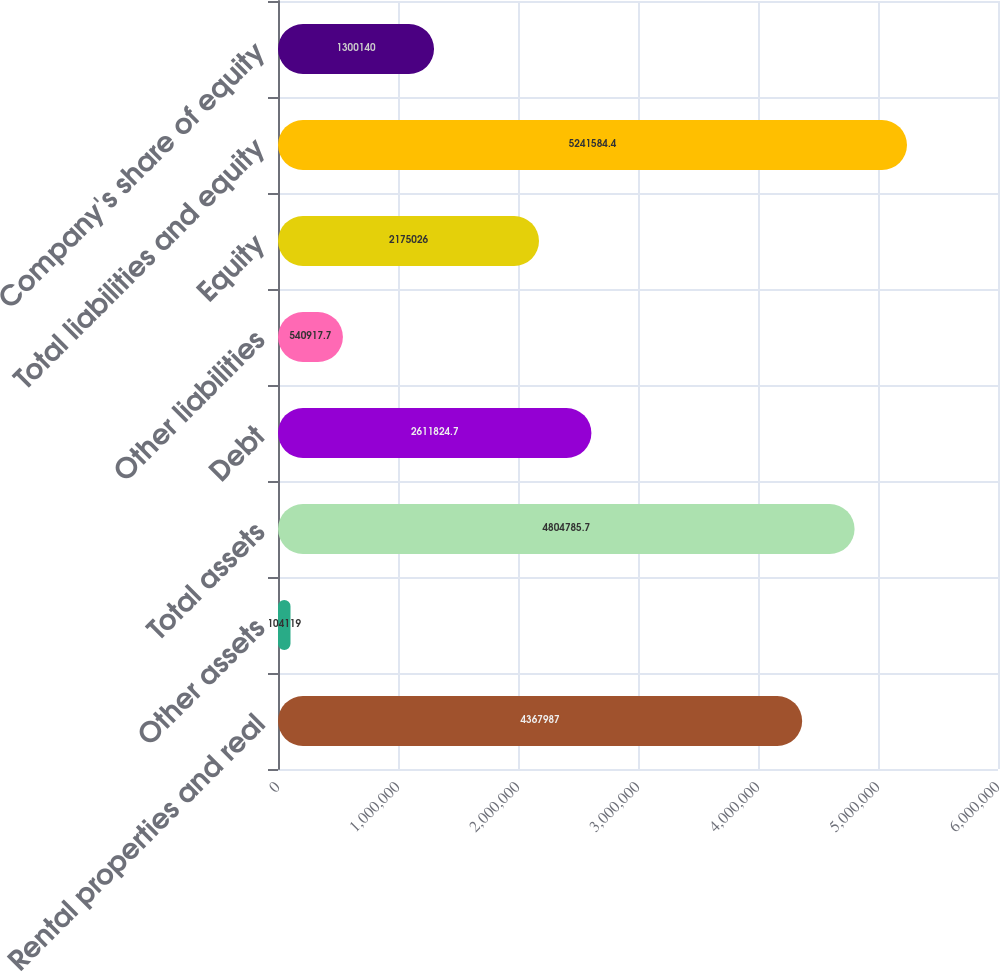Convert chart. <chart><loc_0><loc_0><loc_500><loc_500><bar_chart><fcel>Rental properties and real<fcel>Other assets<fcel>Total assets<fcel>Debt<fcel>Other liabilities<fcel>Equity<fcel>Total liabilities and equity<fcel>Company's share of equity<nl><fcel>4.36799e+06<fcel>104119<fcel>4.80479e+06<fcel>2.61182e+06<fcel>540918<fcel>2.17503e+06<fcel>5.24158e+06<fcel>1.30014e+06<nl></chart> 